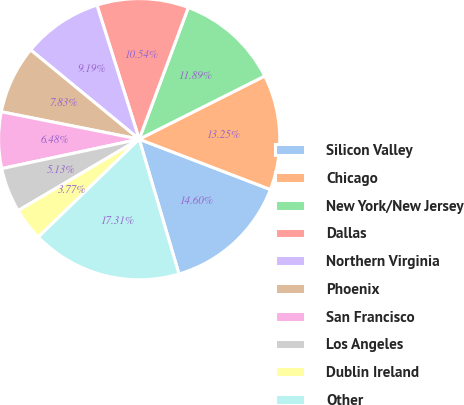Convert chart. <chart><loc_0><loc_0><loc_500><loc_500><pie_chart><fcel>Silicon Valley<fcel>Chicago<fcel>New York/New Jersey<fcel>Dallas<fcel>Northern Virginia<fcel>Phoenix<fcel>San Francisco<fcel>Los Angeles<fcel>Dublin Ireland<fcel>Other<nl><fcel>14.6%<fcel>13.25%<fcel>11.89%<fcel>10.54%<fcel>9.19%<fcel>7.83%<fcel>6.48%<fcel>5.13%<fcel>3.77%<fcel>17.31%<nl></chart> 